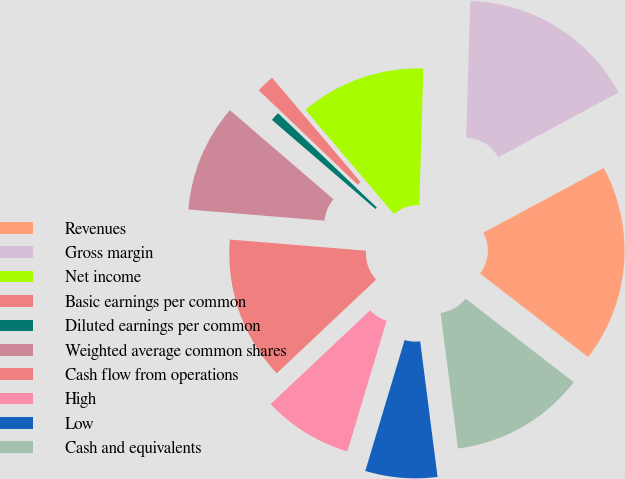<chart> <loc_0><loc_0><loc_500><loc_500><pie_chart><fcel>Revenues<fcel>Gross margin<fcel>Net income<fcel>Basic earnings per common<fcel>Diluted earnings per common<fcel>Weighted average common shares<fcel>Cash flow from operations<fcel>High<fcel>Low<fcel>Cash and equivalents<nl><fcel>18.33%<fcel>16.67%<fcel>11.67%<fcel>1.67%<fcel>0.83%<fcel>10.0%<fcel>13.33%<fcel>8.33%<fcel>6.67%<fcel>12.5%<nl></chart> 